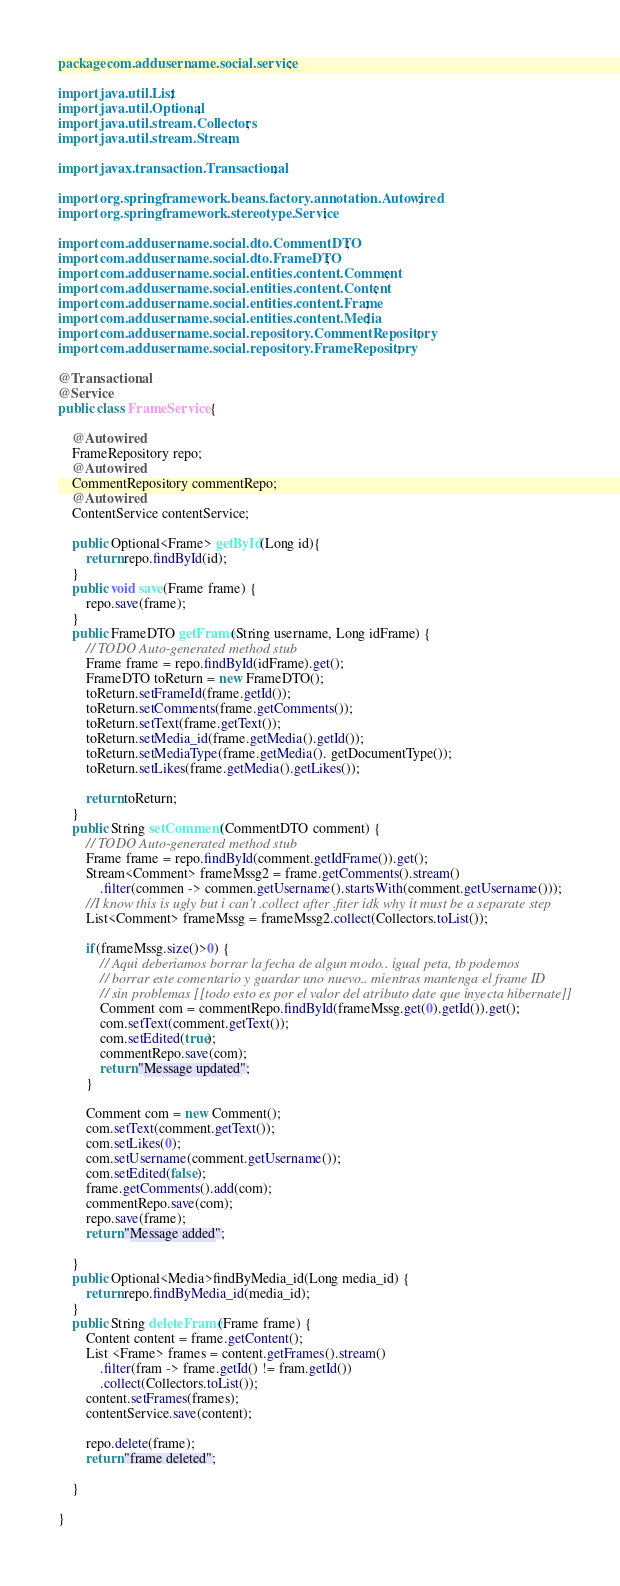Convert code to text. <code><loc_0><loc_0><loc_500><loc_500><_Java_>package com.addusername.social.service;

import java.util.List;
import java.util.Optional;
import java.util.stream.Collectors;
import java.util.stream.Stream;

import javax.transaction.Transactional;

import org.springframework.beans.factory.annotation.Autowired;
import org.springframework.stereotype.Service;

import com.addusername.social.dto.CommentDTO;
import com.addusername.social.dto.FrameDTO;
import com.addusername.social.entities.content.Comment;
import com.addusername.social.entities.content.Content;
import com.addusername.social.entities.content.Frame;
import com.addusername.social.entities.content.Media;
import com.addusername.social.repository.CommentRepository;
import com.addusername.social.repository.FrameRepository;

@Transactional
@Service
public class FrameService {
	
	@Autowired
	FrameRepository repo;
	@Autowired
	CommentRepository commentRepo;
	@Autowired
	ContentService contentService;
	
	public Optional<Frame> getById(Long id){
		return repo.findById(id);		
	}
	public void save(Frame frame) {
		repo.save(frame);
	}
	public FrameDTO getFrame(String username, Long idFrame) {
		// TODO Auto-generated method stub
		Frame frame = repo.findById(idFrame).get();
		FrameDTO toReturn = new FrameDTO();
		toReturn.setFrameId(frame.getId());
		toReturn.setComments(frame.getComments());
		toReturn.setText(frame.getText());
		toReturn.setMedia_id(frame.getMedia().getId());
		toReturn.setMediaType(frame.getMedia(). getDocumentType());
		toReturn.setLikes(frame.getMedia().getLikes());
		
		return toReturn;
	}
	public String setComment(CommentDTO comment) {
		// TODO Auto-generated method stub
		Frame frame = repo.findById(comment.getIdFrame()).get();
		Stream<Comment> frameMssg2 = frame.getComments().stream()
			.filter(commen -> commen.getUsername().startsWith(comment.getUsername()));
		//I know this is ugly but i can't .collect after .fiter idk why it must be a separate step
		List<Comment> frameMssg = frameMssg2.collect(Collectors.toList());	
			
		if(frameMssg.size()>0) {
			// Aqui deberiamos borrar la fecha de algun modo.. igual peta, tb podemos 
			// borrar este comentario y guardar uno nuevo.. mientras mantenga el frame ID
			// sin problemas [[todo esto es por el valor del atributo date que inyecta hibernate]]
			Comment com = commentRepo.findById(frameMssg.get(0).getId()).get();
			com.setText(comment.getText());
			com.setEdited(true);
			commentRepo.save(com);
			return "Message updated";
		}
		
		Comment com = new Comment();
		com.setText(comment.getText());
		com.setLikes(0);
		com.setUsername(comment.getUsername());
		com.setEdited(false);
		frame.getComments().add(com);
		commentRepo.save(com);	
		repo.save(frame);
		return "Message added";
		
	}
	public Optional<Media>findByMedia_id(Long media_id) {
		return repo.findByMedia_id(media_id);		
	}
	public String deleteFrame(Frame frame) {
		Content content = frame.getContent();
		List <Frame> frames = content.getFrames().stream()
			.filter(fram -> frame.getId() != fram.getId())
			.collect(Collectors.toList());
		content.setFrames(frames);
		contentService.save(content);
		
		repo.delete(frame);
		return "frame deleted";
		
	}

}
</code> 